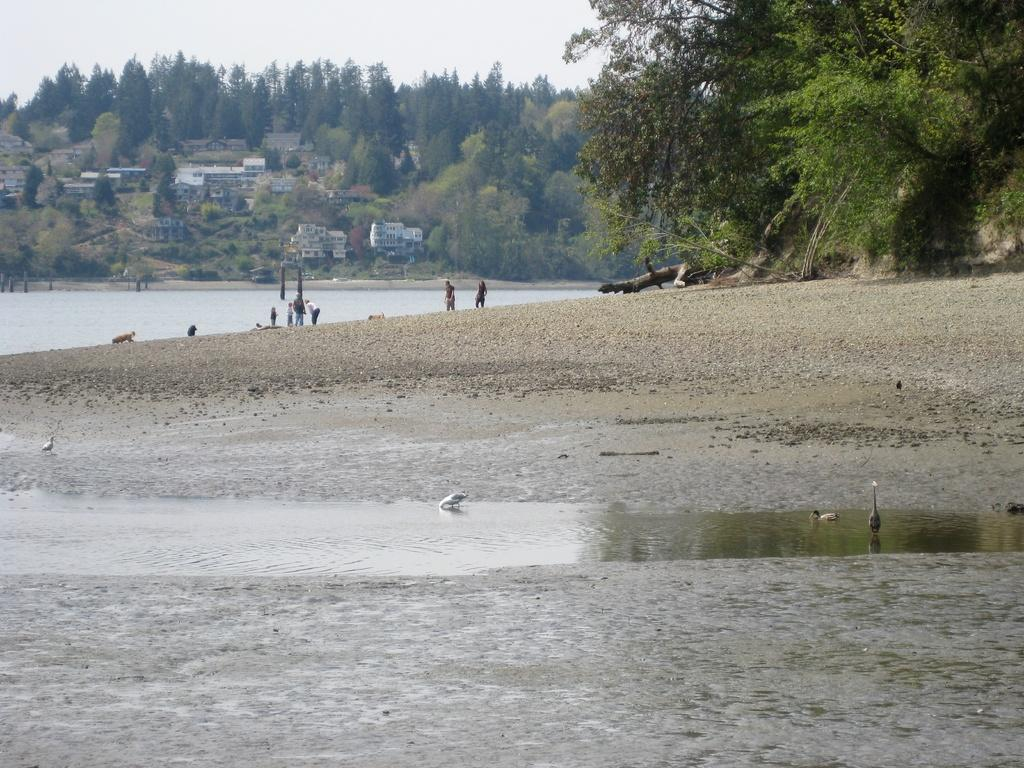What is the location of the people in the image? The people are standing on the shore of the water. What can be seen in the background of the image? There are trees and houses in the background of the image. What type of cloth is being used by the owl in the image? There is no owl present in the image, so it is not possible to determine what type of cloth it might be using. 